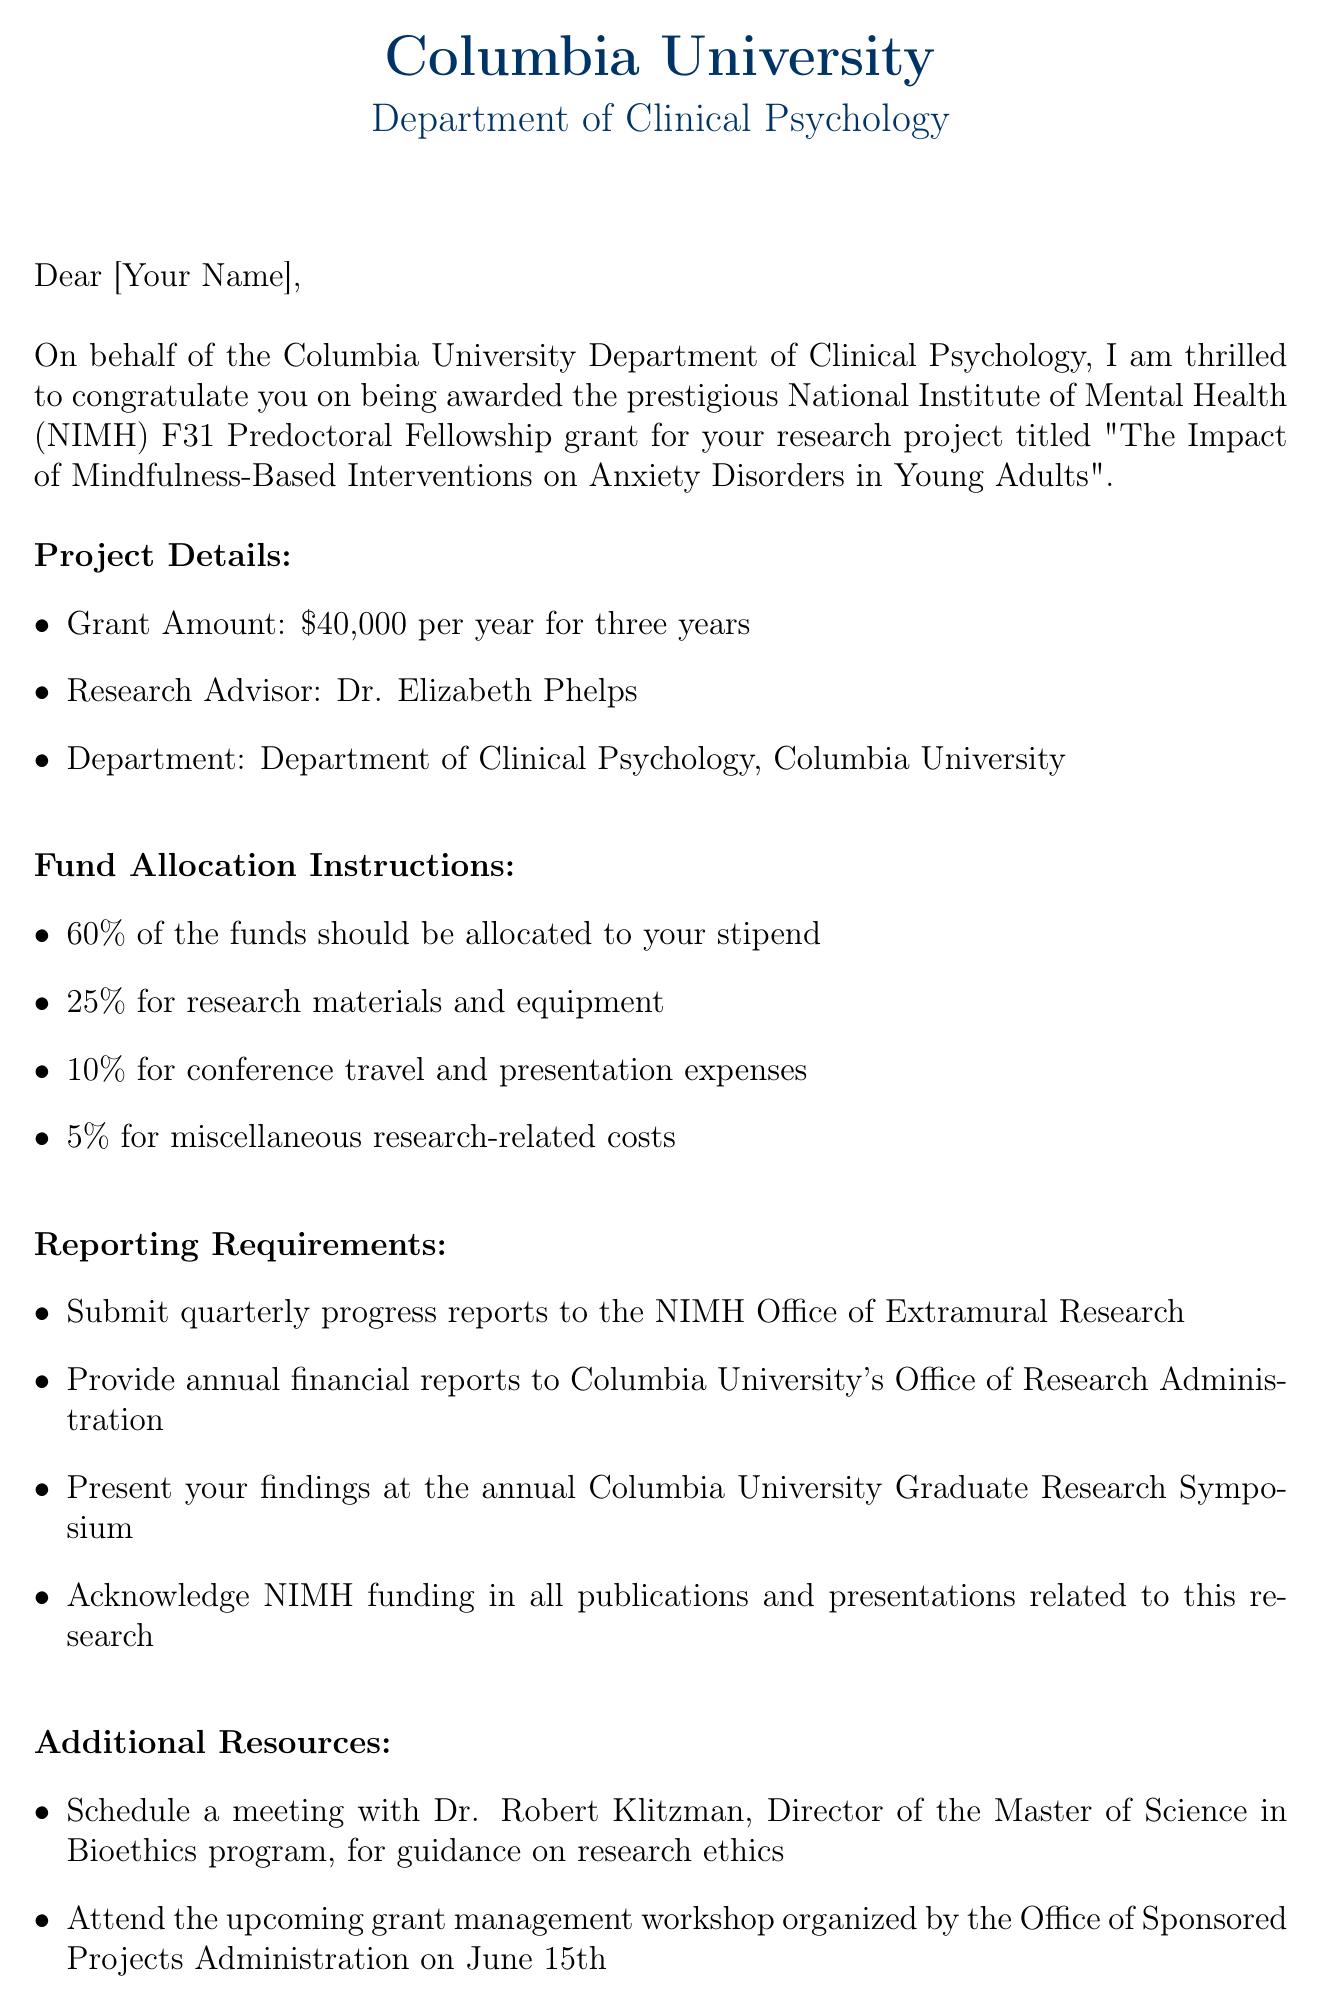What is the grant amount? The grant amount is specifically stated in the document, which is $40,000 per year for three years.
Answer: $40,000 per year for three years Who is the research advisor? The document lists the research advisor under project details, which is Dr. Elizabeth Phelps.
Answer: Dr. Elizabeth Phelps What percentage of the funds should be allocated to the stipend? The allocation for the stipend is detailed in the fund allocation instructions, where it states 60% should be allocated.
Answer: 60% What are the reporting requirements for the grant? The document outlines several specific reporting requirements, such as submitting quarterly progress reports and providing annual financial reports.
Answer: Submit quarterly progress reports to the NIMH Office of Extramural Research What is the title of the research project? The title is mentioned explicitly in the document as "The Impact of Mindfulness-Based Interventions on Anxiety Disorders in Young Adults".
Answer: The Impact of Mindfulness-Based Interventions on Anxiety Disorders in Young Adults Which office should the financial reports be submitted to? The document specifies that annual financial reports should be provided to Columbia University's Office of Research Administration.
Answer: Columbia University's Office of Research Administration What workshop should the recipient attend? The document suggests attending a grant management workshop organized by the Office of Sponsored Projects Administration on June 15th.
Answer: Grant management workshop on June 15th Who authored the letter? The signature section of the document reveals the author of the letter as Dr. Marla Brassard.
Answer: Dr. Marla Brassard 